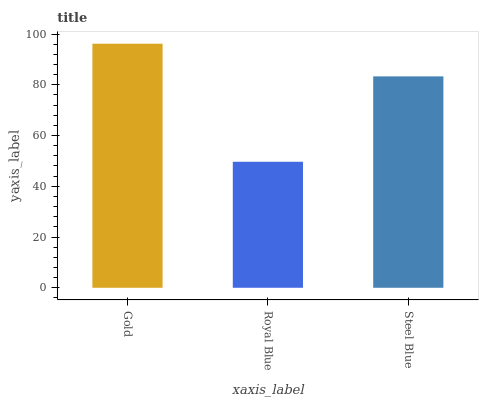Is Royal Blue the minimum?
Answer yes or no. Yes. Is Gold the maximum?
Answer yes or no. Yes. Is Steel Blue the minimum?
Answer yes or no. No. Is Steel Blue the maximum?
Answer yes or no. No. Is Steel Blue greater than Royal Blue?
Answer yes or no. Yes. Is Royal Blue less than Steel Blue?
Answer yes or no. Yes. Is Royal Blue greater than Steel Blue?
Answer yes or no. No. Is Steel Blue less than Royal Blue?
Answer yes or no. No. Is Steel Blue the high median?
Answer yes or no. Yes. Is Steel Blue the low median?
Answer yes or no. Yes. Is Gold the high median?
Answer yes or no. No. Is Royal Blue the low median?
Answer yes or no. No. 